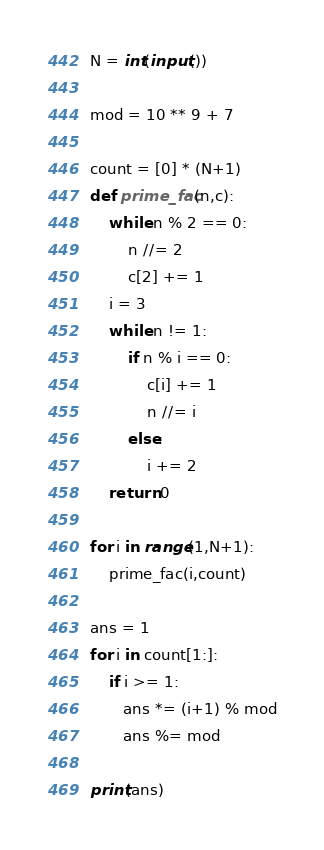Convert code to text. <code><loc_0><loc_0><loc_500><loc_500><_Python_>N = int(input())

mod = 10 ** 9 + 7

count = [0] * (N+1)
def prime_fac(n,c):
    while n % 2 == 0:
        n //= 2
        c[2] += 1
    i = 3
    while n != 1:
        if n % i == 0:
            c[i] += 1
            n //= i
        else:
            i += 2
    return 0
        
for i in range(1,N+1):
    prime_fac(i,count)

ans = 1
for i in count[1:]:
    if i >= 1:
       ans *= (i+1) % mod
       ans %= mod

print(ans)</code> 